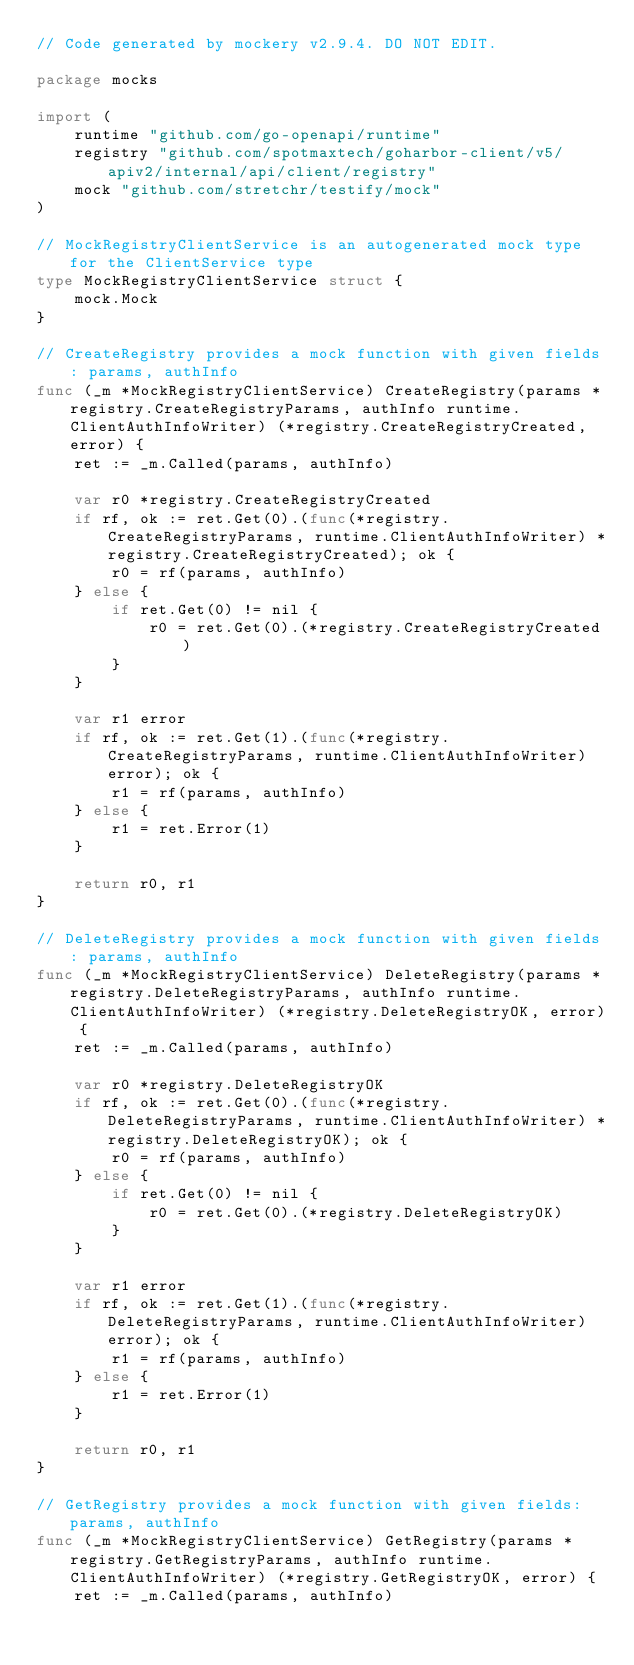<code> <loc_0><loc_0><loc_500><loc_500><_Go_>// Code generated by mockery v2.9.4. DO NOT EDIT.

package mocks

import (
	runtime "github.com/go-openapi/runtime"
	registry "github.com/spotmaxtech/goharbor-client/v5/apiv2/internal/api/client/registry"
	mock "github.com/stretchr/testify/mock"
)

// MockRegistryClientService is an autogenerated mock type for the ClientService type
type MockRegistryClientService struct {
	mock.Mock
}

// CreateRegistry provides a mock function with given fields: params, authInfo
func (_m *MockRegistryClientService) CreateRegistry(params *registry.CreateRegistryParams, authInfo runtime.ClientAuthInfoWriter) (*registry.CreateRegistryCreated, error) {
	ret := _m.Called(params, authInfo)

	var r0 *registry.CreateRegistryCreated
	if rf, ok := ret.Get(0).(func(*registry.CreateRegistryParams, runtime.ClientAuthInfoWriter) *registry.CreateRegistryCreated); ok {
		r0 = rf(params, authInfo)
	} else {
		if ret.Get(0) != nil {
			r0 = ret.Get(0).(*registry.CreateRegistryCreated)
		}
	}

	var r1 error
	if rf, ok := ret.Get(1).(func(*registry.CreateRegistryParams, runtime.ClientAuthInfoWriter) error); ok {
		r1 = rf(params, authInfo)
	} else {
		r1 = ret.Error(1)
	}

	return r0, r1
}

// DeleteRegistry provides a mock function with given fields: params, authInfo
func (_m *MockRegistryClientService) DeleteRegistry(params *registry.DeleteRegistryParams, authInfo runtime.ClientAuthInfoWriter) (*registry.DeleteRegistryOK, error) {
	ret := _m.Called(params, authInfo)

	var r0 *registry.DeleteRegistryOK
	if rf, ok := ret.Get(0).(func(*registry.DeleteRegistryParams, runtime.ClientAuthInfoWriter) *registry.DeleteRegistryOK); ok {
		r0 = rf(params, authInfo)
	} else {
		if ret.Get(0) != nil {
			r0 = ret.Get(0).(*registry.DeleteRegistryOK)
		}
	}

	var r1 error
	if rf, ok := ret.Get(1).(func(*registry.DeleteRegistryParams, runtime.ClientAuthInfoWriter) error); ok {
		r1 = rf(params, authInfo)
	} else {
		r1 = ret.Error(1)
	}

	return r0, r1
}

// GetRegistry provides a mock function with given fields: params, authInfo
func (_m *MockRegistryClientService) GetRegistry(params *registry.GetRegistryParams, authInfo runtime.ClientAuthInfoWriter) (*registry.GetRegistryOK, error) {
	ret := _m.Called(params, authInfo)
</code> 